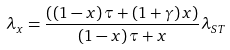Convert formula to latex. <formula><loc_0><loc_0><loc_500><loc_500>\lambda _ { x } = \frac { { \left ( { \left ( { 1 - x } \right ) \tau + \left ( { 1 + \gamma } \right ) x } \right ) } } { { \left ( { 1 - x } \right ) \tau + x } } \lambda _ { S T }</formula> 